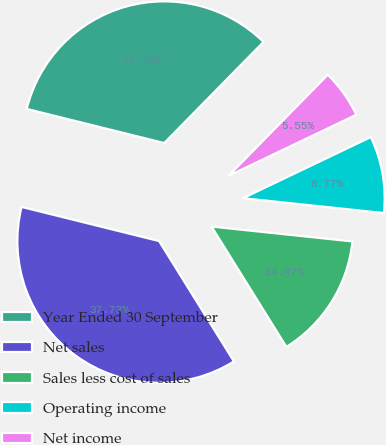Convert chart to OTSL. <chart><loc_0><loc_0><loc_500><loc_500><pie_chart><fcel>Year Ended 30 September<fcel>Net sales<fcel>Sales less cost of sales<fcel>Operating income<fcel>Net income<nl><fcel>33.48%<fcel>37.73%<fcel>14.47%<fcel>8.77%<fcel>5.55%<nl></chart> 